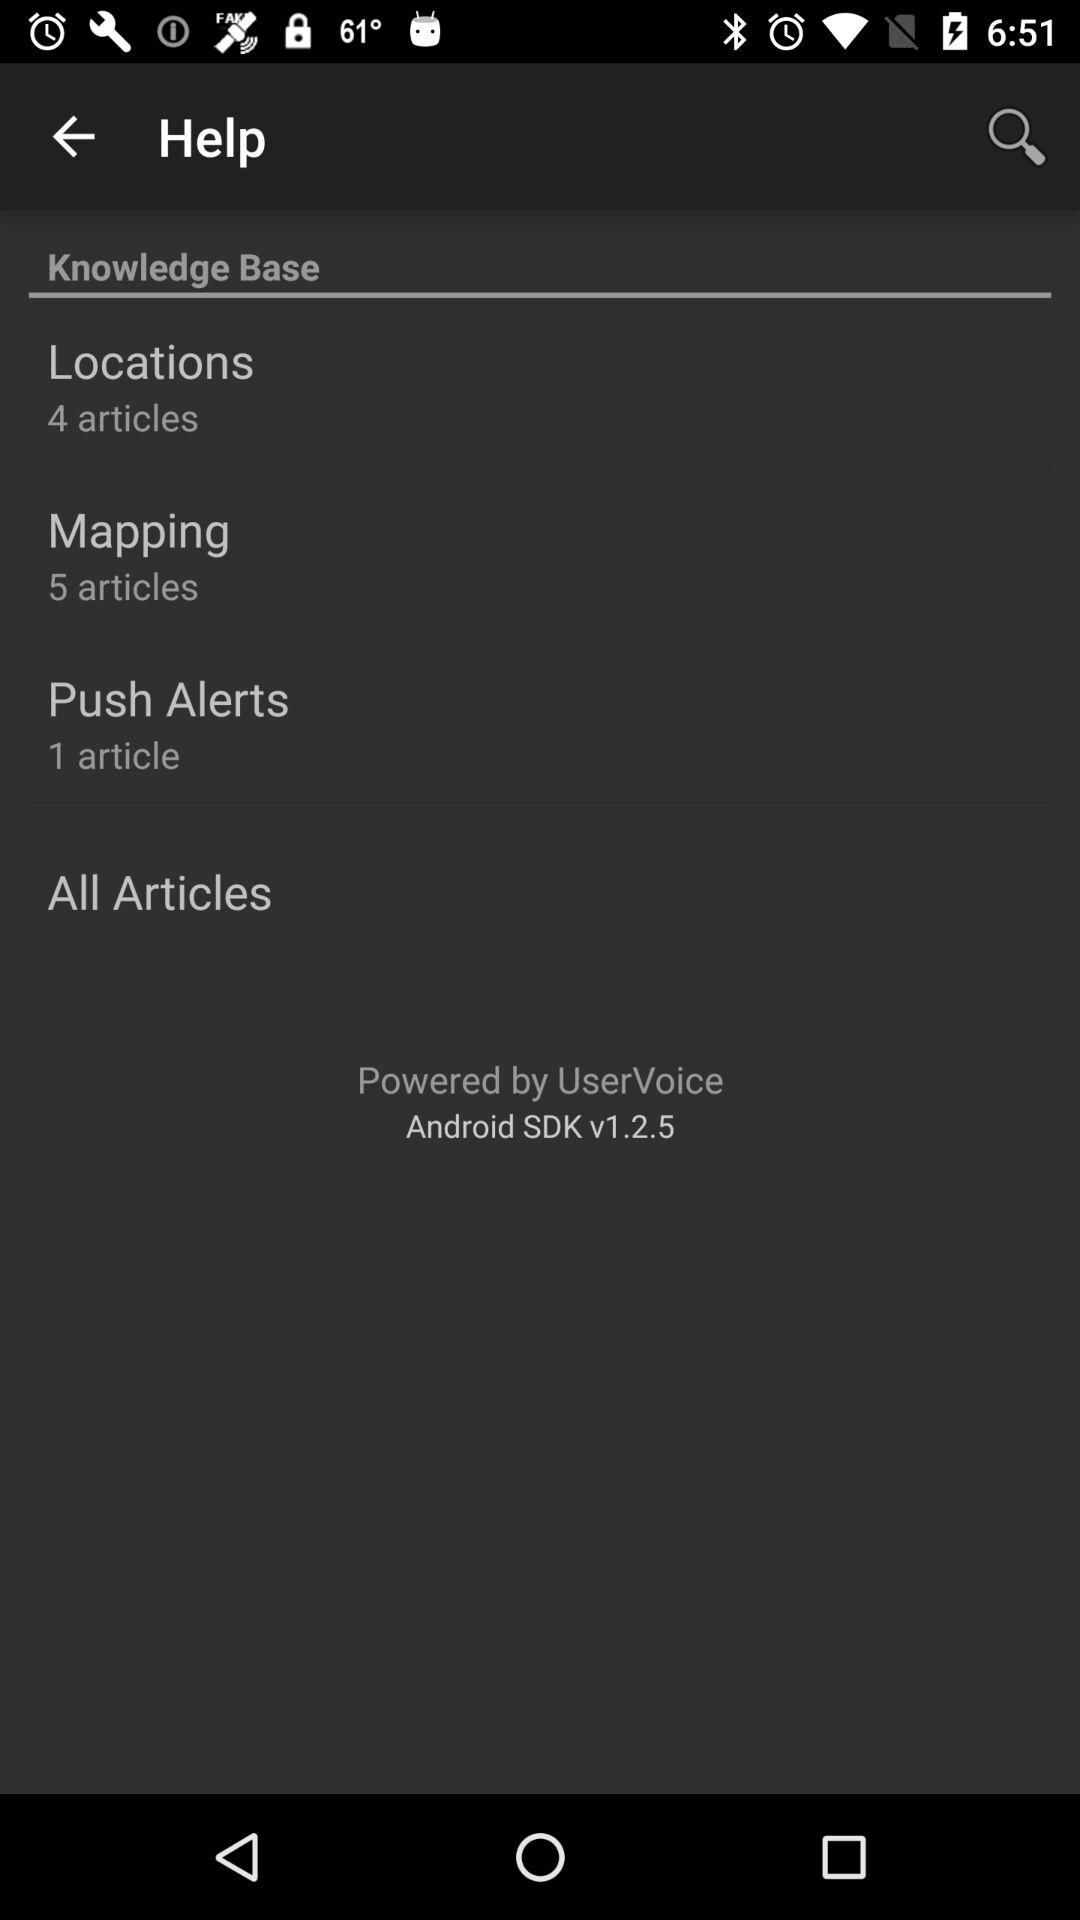How many articles are there in total?
Answer the question using a single word or phrase. 10 